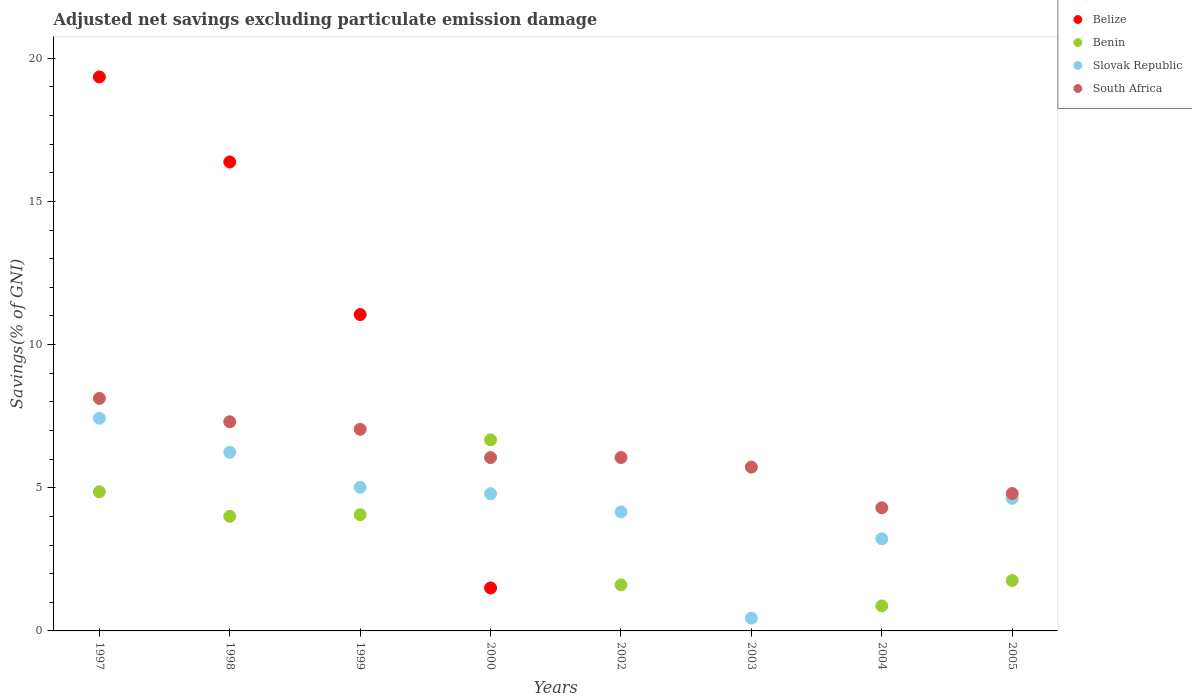Is the number of dotlines equal to the number of legend labels?
Your answer should be very brief. No. What is the adjusted net savings in Belize in 2000?
Your answer should be very brief. 1.5. Across all years, what is the maximum adjusted net savings in Benin?
Keep it short and to the point. 6.67. Across all years, what is the minimum adjusted net savings in Slovak Republic?
Provide a short and direct response. 0.44. What is the total adjusted net savings in Slovak Republic in the graph?
Offer a terse response. 35.91. What is the difference between the adjusted net savings in South Africa in 1998 and that in 2004?
Offer a very short reply. 3. What is the difference between the adjusted net savings in Benin in 2004 and the adjusted net savings in South Africa in 2005?
Offer a very short reply. -3.92. What is the average adjusted net savings in Slovak Republic per year?
Provide a short and direct response. 4.49. In the year 2000, what is the difference between the adjusted net savings in Benin and adjusted net savings in Belize?
Offer a terse response. 5.17. What is the ratio of the adjusted net savings in South Africa in 1997 to that in 1998?
Provide a short and direct response. 1.11. Is the adjusted net savings in Benin in 2000 less than that in 2005?
Ensure brevity in your answer.  No. Is the difference between the adjusted net savings in Benin in 1997 and 2000 greater than the difference between the adjusted net savings in Belize in 1997 and 2000?
Your answer should be compact. No. What is the difference between the highest and the second highest adjusted net savings in South Africa?
Your answer should be compact. 0.81. What is the difference between the highest and the lowest adjusted net savings in South Africa?
Keep it short and to the point. 3.82. In how many years, is the adjusted net savings in Belize greater than the average adjusted net savings in Belize taken over all years?
Give a very brief answer. 3. Is the sum of the adjusted net savings in South Africa in 2000 and 2002 greater than the maximum adjusted net savings in Belize across all years?
Your response must be concise. No. Is it the case that in every year, the sum of the adjusted net savings in Slovak Republic and adjusted net savings in South Africa  is greater than the sum of adjusted net savings in Benin and adjusted net savings in Belize?
Offer a very short reply. No. Is it the case that in every year, the sum of the adjusted net savings in Slovak Republic and adjusted net savings in Benin  is greater than the adjusted net savings in South Africa?
Your response must be concise. No. Does the adjusted net savings in Benin monotonically increase over the years?
Your answer should be compact. No. What is the difference between two consecutive major ticks on the Y-axis?
Make the answer very short. 5. Does the graph contain any zero values?
Provide a succinct answer. Yes. Does the graph contain grids?
Ensure brevity in your answer.  No. What is the title of the graph?
Ensure brevity in your answer.  Adjusted net savings excluding particulate emission damage. What is the label or title of the Y-axis?
Your response must be concise. Savings(% of GNI). What is the Savings(% of GNI) of Belize in 1997?
Your answer should be compact. 19.35. What is the Savings(% of GNI) in Benin in 1997?
Your answer should be compact. 4.86. What is the Savings(% of GNI) of Slovak Republic in 1997?
Your answer should be compact. 7.43. What is the Savings(% of GNI) in South Africa in 1997?
Provide a succinct answer. 8.12. What is the Savings(% of GNI) in Belize in 1998?
Ensure brevity in your answer.  16.38. What is the Savings(% of GNI) of Benin in 1998?
Give a very brief answer. 4. What is the Savings(% of GNI) in Slovak Republic in 1998?
Ensure brevity in your answer.  6.24. What is the Savings(% of GNI) of South Africa in 1998?
Provide a succinct answer. 7.3. What is the Savings(% of GNI) in Belize in 1999?
Your answer should be very brief. 11.05. What is the Savings(% of GNI) of Benin in 1999?
Provide a succinct answer. 4.06. What is the Savings(% of GNI) of Slovak Republic in 1999?
Offer a very short reply. 5.02. What is the Savings(% of GNI) in South Africa in 1999?
Offer a very short reply. 7.04. What is the Savings(% of GNI) of Belize in 2000?
Provide a succinct answer. 1.5. What is the Savings(% of GNI) of Benin in 2000?
Ensure brevity in your answer.  6.67. What is the Savings(% of GNI) of Slovak Republic in 2000?
Provide a short and direct response. 4.79. What is the Savings(% of GNI) in South Africa in 2000?
Your response must be concise. 6.05. What is the Savings(% of GNI) of Benin in 2002?
Your answer should be very brief. 1.61. What is the Savings(% of GNI) in Slovak Republic in 2002?
Offer a terse response. 4.16. What is the Savings(% of GNI) in South Africa in 2002?
Give a very brief answer. 6.05. What is the Savings(% of GNI) of Belize in 2003?
Provide a succinct answer. 0. What is the Savings(% of GNI) in Slovak Republic in 2003?
Your answer should be very brief. 0.44. What is the Savings(% of GNI) in South Africa in 2003?
Your response must be concise. 5.72. What is the Savings(% of GNI) in Belize in 2004?
Offer a terse response. 0. What is the Savings(% of GNI) in Benin in 2004?
Your answer should be very brief. 0.87. What is the Savings(% of GNI) of Slovak Republic in 2004?
Offer a very short reply. 3.22. What is the Savings(% of GNI) in South Africa in 2004?
Ensure brevity in your answer.  4.3. What is the Savings(% of GNI) in Belize in 2005?
Your answer should be very brief. 0. What is the Savings(% of GNI) in Benin in 2005?
Provide a succinct answer. 1.76. What is the Savings(% of GNI) of Slovak Republic in 2005?
Provide a short and direct response. 4.63. What is the Savings(% of GNI) in South Africa in 2005?
Provide a short and direct response. 4.8. Across all years, what is the maximum Savings(% of GNI) of Belize?
Offer a very short reply. 19.35. Across all years, what is the maximum Savings(% of GNI) of Benin?
Your answer should be very brief. 6.67. Across all years, what is the maximum Savings(% of GNI) in Slovak Republic?
Your answer should be compact. 7.43. Across all years, what is the maximum Savings(% of GNI) in South Africa?
Ensure brevity in your answer.  8.12. Across all years, what is the minimum Savings(% of GNI) of Slovak Republic?
Your response must be concise. 0.44. Across all years, what is the minimum Savings(% of GNI) of South Africa?
Provide a short and direct response. 4.3. What is the total Savings(% of GNI) in Belize in the graph?
Make the answer very short. 48.27. What is the total Savings(% of GNI) in Benin in the graph?
Offer a very short reply. 23.83. What is the total Savings(% of GNI) of Slovak Republic in the graph?
Your answer should be very brief. 35.91. What is the total Savings(% of GNI) in South Africa in the graph?
Make the answer very short. 49.39. What is the difference between the Savings(% of GNI) in Belize in 1997 and that in 1998?
Give a very brief answer. 2.97. What is the difference between the Savings(% of GNI) in Benin in 1997 and that in 1998?
Provide a succinct answer. 0.86. What is the difference between the Savings(% of GNI) in Slovak Republic in 1997 and that in 1998?
Give a very brief answer. 1.19. What is the difference between the Savings(% of GNI) of South Africa in 1997 and that in 1998?
Ensure brevity in your answer.  0.81. What is the difference between the Savings(% of GNI) in Belize in 1997 and that in 1999?
Your answer should be very brief. 8.3. What is the difference between the Savings(% of GNI) in Benin in 1997 and that in 1999?
Your answer should be very brief. 0.8. What is the difference between the Savings(% of GNI) of Slovak Republic in 1997 and that in 1999?
Ensure brevity in your answer.  2.41. What is the difference between the Savings(% of GNI) of South Africa in 1997 and that in 1999?
Keep it short and to the point. 1.08. What is the difference between the Savings(% of GNI) in Belize in 1997 and that in 2000?
Make the answer very short. 17.85. What is the difference between the Savings(% of GNI) of Benin in 1997 and that in 2000?
Give a very brief answer. -1.81. What is the difference between the Savings(% of GNI) in Slovak Republic in 1997 and that in 2000?
Offer a very short reply. 2.64. What is the difference between the Savings(% of GNI) of South Africa in 1997 and that in 2000?
Offer a terse response. 2.07. What is the difference between the Savings(% of GNI) of Benin in 1997 and that in 2002?
Your response must be concise. 3.25. What is the difference between the Savings(% of GNI) in Slovak Republic in 1997 and that in 2002?
Make the answer very short. 3.27. What is the difference between the Savings(% of GNI) in South Africa in 1997 and that in 2002?
Your answer should be compact. 2.06. What is the difference between the Savings(% of GNI) in Slovak Republic in 1997 and that in 2003?
Keep it short and to the point. 6.98. What is the difference between the Savings(% of GNI) of South Africa in 1997 and that in 2003?
Make the answer very short. 2.4. What is the difference between the Savings(% of GNI) of Benin in 1997 and that in 2004?
Ensure brevity in your answer.  3.99. What is the difference between the Savings(% of GNI) in Slovak Republic in 1997 and that in 2004?
Provide a short and direct response. 4.21. What is the difference between the Savings(% of GNI) in South Africa in 1997 and that in 2004?
Offer a very short reply. 3.82. What is the difference between the Savings(% of GNI) of Slovak Republic in 1997 and that in 2005?
Your answer should be very brief. 2.8. What is the difference between the Savings(% of GNI) of South Africa in 1997 and that in 2005?
Provide a short and direct response. 3.32. What is the difference between the Savings(% of GNI) of Belize in 1998 and that in 1999?
Provide a short and direct response. 5.33. What is the difference between the Savings(% of GNI) of Benin in 1998 and that in 1999?
Ensure brevity in your answer.  -0.06. What is the difference between the Savings(% of GNI) in Slovak Republic in 1998 and that in 1999?
Keep it short and to the point. 1.22. What is the difference between the Savings(% of GNI) of South Africa in 1998 and that in 1999?
Your response must be concise. 0.26. What is the difference between the Savings(% of GNI) in Belize in 1998 and that in 2000?
Make the answer very short. 14.88. What is the difference between the Savings(% of GNI) of Benin in 1998 and that in 2000?
Give a very brief answer. -2.67. What is the difference between the Savings(% of GNI) in Slovak Republic in 1998 and that in 2000?
Make the answer very short. 1.45. What is the difference between the Savings(% of GNI) of South Africa in 1998 and that in 2000?
Give a very brief answer. 1.25. What is the difference between the Savings(% of GNI) in Benin in 1998 and that in 2002?
Ensure brevity in your answer.  2.39. What is the difference between the Savings(% of GNI) of Slovak Republic in 1998 and that in 2002?
Make the answer very short. 2.08. What is the difference between the Savings(% of GNI) in South Africa in 1998 and that in 2002?
Provide a short and direct response. 1.25. What is the difference between the Savings(% of GNI) in Slovak Republic in 1998 and that in 2003?
Give a very brief answer. 5.79. What is the difference between the Savings(% of GNI) in South Africa in 1998 and that in 2003?
Provide a short and direct response. 1.58. What is the difference between the Savings(% of GNI) in Benin in 1998 and that in 2004?
Ensure brevity in your answer.  3.13. What is the difference between the Savings(% of GNI) of Slovak Republic in 1998 and that in 2004?
Your answer should be very brief. 3.02. What is the difference between the Savings(% of GNI) in South Africa in 1998 and that in 2004?
Your answer should be very brief. 3. What is the difference between the Savings(% of GNI) in Benin in 1998 and that in 2005?
Keep it short and to the point. 2.24. What is the difference between the Savings(% of GNI) in Slovak Republic in 1998 and that in 2005?
Provide a succinct answer. 1.61. What is the difference between the Savings(% of GNI) of South Africa in 1998 and that in 2005?
Provide a short and direct response. 2.51. What is the difference between the Savings(% of GNI) of Belize in 1999 and that in 2000?
Your answer should be very brief. 9.55. What is the difference between the Savings(% of GNI) in Benin in 1999 and that in 2000?
Make the answer very short. -2.62. What is the difference between the Savings(% of GNI) in Slovak Republic in 1999 and that in 2000?
Provide a short and direct response. 0.23. What is the difference between the Savings(% of GNI) in South Africa in 1999 and that in 2000?
Provide a short and direct response. 0.99. What is the difference between the Savings(% of GNI) in Benin in 1999 and that in 2002?
Offer a very short reply. 2.45. What is the difference between the Savings(% of GNI) in Slovak Republic in 1999 and that in 2002?
Give a very brief answer. 0.86. What is the difference between the Savings(% of GNI) of South Africa in 1999 and that in 2002?
Your answer should be compact. 0.99. What is the difference between the Savings(% of GNI) of Slovak Republic in 1999 and that in 2003?
Provide a succinct answer. 4.57. What is the difference between the Savings(% of GNI) in South Africa in 1999 and that in 2003?
Keep it short and to the point. 1.32. What is the difference between the Savings(% of GNI) of Benin in 1999 and that in 2004?
Make the answer very short. 3.18. What is the difference between the Savings(% of GNI) in Slovak Republic in 1999 and that in 2004?
Provide a short and direct response. 1.8. What is the difference between the Savings(% of GNI) in South Africa in 1999 and that in 2004?
Keep it short and to the point. 2.74. What is the difference between the Savings(% of GNI) of Benin in 1999 and that in 2005?
Ensure brevity in your answer.  2.3. What is the difference between the Savings(% of GNI) of Slovak Republic in 1999 and that in 2005?
Your answer should be very brief. 0.39. What is the difference between the Savings(% of GNI) in South Africa in 1999 and that in 2005?
Make the answer very short. 2.24. What is the difference between the Savings(% of GNI) of Benin in 2000 and that in 2002?
Your answer should be compact. 5.07. What is the difference between the Savings(% of GNI) in Slovak Republic in 2000 and that in 2002?
Offer a very short reply. 0.63. What is the difference between the Savings(% of GNI) in South Africa in 2000 and that in 2002?
Provide a short and direct response. -0. What is the difference between the Savings(% of GNI) in Slovak Republic in 2000 and that in 2003?
Keep it short and to the point. 4.34. What is the difference between the Savings(% of GNI) in South Africa in 2000 and that in 2003?
Ensure brevity in your answer.  0.33. What is the difference between the Savings(% of GNI) in Benin in 2000 and that in 2004?
Provide a short and direct response. 5.8. What is the difference between the Savings(% of GNI) in Slovak Republic in 2000 and that in 2004?
Offer a terse response. 1.57. What is the difference between the Savings(% of GNI) of South Africa in 2000 and that in 2004?
Make the answer very short. 1.75. What is the difference between the Savings(% of GNI) of Benin in 2000 and that in 2005?
Make the answer very short. 4.91. What is the difference between the Savings(% of GNI) of Slovak Republic in 2000 and that in 2005?
Give a very brief answer. 0.16. What is the difference between the Savings(% of GNI) in South Africa in 2000 and that in 2005?
Offer a terse response. 1.25. What is the difference between the Savings(% of GNI) of Slovak Republic in 2002 and that in 2003?
Provide a short and direct response. 3.71. What is the difference between the Savings(% of GNI) in South Africa in 2002 and that in 2003?
Offer a terse response. 0.33. What is the difference between the Savings(% of GNI) in Benin in 2002 and that in 2004?
Ensure brevity in your answer.  0.73. What is the difference between the Savings(% of GNI) in Slovak Republic in 2002 and that in 2004?
Offer a terse response. 0.94. What is the difference between the Savings(% of GNI) of South Africa in 2002 and that in 2004?
Keep it short and to the point. 1.75. What is the difference between the Savings(% of GNI) in Benin in 2002 and that in 2005?
Keep it short and to the point. -0.15. What is the difference between the Savings(% of GNI) of Slovak Republic in 2002 and that in 2005?
Your response must be concise. -0.47. What is the difference between the Savings(% of GNI) in South Africa in 2002 and that in 2005?
Your answer should be very brief. 1.26. What is the difference between the Savings(% of GNI) of Slovak Republic in 2003 and that in 2004?
Your answer should be very brief. -2.77. What is the difference between the Savings(% of GNI) of South Africa in 2003 and that in 2004?
Provide a succinct answer. 1.42. What is the difference between the Savings(% of GNI) in Slovak Republic in 2003 and that in 2005?
Give a very brief answer. -4.18. What is the difference between the Savings(% of GNI) in South Africa in 2003 and that in 2005?
Ensure brevity in your answer.  0.92. What is the difference between the Savings(% of GNI) in Benin in 2004 and that in 2005?
Offer a terse response. -0.89. What is the difference between the Savings(% of GNI) in Slovak Republic in 2004 and that in 2005?
Your answer should be compact. -1.41. What is the difference between the Savings(% of GNI) of South Africa in 2004 and that in 2005?
Offer a very short reply. -0.5. What is the difference between the Savings(% of GNI) in Belize in 1997 and the Savings(% of GNI) in Benin in 1998?
Ensure brevity in your answer.  15.35. What is the difference between the Savings(% of GNI) of Belize in 1997 and the Savings(% of GNI) of Slovak Republic in 1998?
Give a very brief answer. 13.11. What is the difference between the Savings(% of GNI) of Belize in 1997 and the Savings(% of GNI) of South Africa in 1998?
Provide a short and direct response. 12.04. What is the difference between the Savings(% of GNI) in Benin in 1997 and the Savings(% of GNI) in Slovak Republic in 1998?
Provide a succinct answer. -1.38. What is the difference between the Savings(% of GNI) in Benin in 1997 and the Savings(% of GNI) in South Africa in 1998?
Ensure brevity in your answer.  -2.45. What is the difference between the Savings(% of GNI) in Slovak Republic in 1997 and the Savings(% of GNI) in South Africa in 1998?
Give a very brief answer. 0.12. What is the difference between the Savings(% of GNI) of Belize in 1997 and the Savings(% of GNI) of Benin in 1999?
Make the answer very short. 15.29. What is the difference between the Savings(% of GNI) in Belize in 1997 and the Savings(% of GNI) in Slovak Republic in 1999?
Offer a terse response. 14.33. What is the difference between the Savings(% of GNI) in Belize in 1997 and the Savings(% of GNI) in South Africa in 1999?
Provide a succinct answer. 12.31. What is the difference between the Savings(% of GNI) of Benin in 1997 and the Savings(% of GNI) of Slovak Republic in 1999?
Provide a short and direct response. -0.16. What is the difference between the Savings(% of GNI) of Benin in 1997 and the Savings(% of GNI) of South Africa in 1999?
Keep it short and to the point. -2.18. What is the difference between the Savings(% of GNI) in Slovak Republic in 1997 and the Savings(% of GNI) in South Africa in 1999?
Provide a succinct answer. 0.39. What is the difference between the Savings(% of GNI) in Belize in 1997 and the Savings(% of GNI) in Benin in 2000?
Your answer should be very brief. 12.67. What is the difference between the Savings(% of GNI) of Belize in 1997 and the Savings(% of GNI) of Slovak Republic in 2000?
Make the answer very short. 14.56. What is the difference between the Savings(% of GNI) in Belize in 1997 and the Savings(% of GNI) in South Africa in 2000?
Provide a succinct answer. 13.29. What is the difference between the Savings(% of GNI) of Benin in 1997 and the Savings(% of GNI) of Slovak Republic in 2000?
Ensure brevity in your answer.  0.07. What is the difference between the Savings(% of GNI) in Benin in 1997 and the Savings(% of GNI) in South Africa in 2000?
Offer a terse response. -1.19. What is the difference between the Savings(% of GNI) in Slovak Republic in 1997 and the Savings(% of GNI) in South Africa in 2000?
Make the answer very short. 1.37. What is the difference between the Savings(% of GNI) in Belize in 1997 and the Savings(% of GNI) in Benin in 2002?
Make the answer very short. 17.74. What is the difference between the Savings(% of GNI) of Belize in 1997 and the Savings(% of GNI) of Slovak Republic in 2002?
Keep it short and to the point. 15.19. What is the difference between the Savings(% of GNI) of Belize in 1997 and the Savings(% of GNI) of South Africa in 2002?
Provide a short and direct response. 13.29. What is the difference between the Savings(% of GNI) in Benin in 1997 and the Savings(% of GNI) in Slovak Republic in 2002?
Provide a succinct answer. 0.7. What is the difference between the Savings(% of GNI) in Benin in 1997 and the Savings(% of GNI) in South Africa in 2002?
Offer a terse response. -1.2. What is the difference between the Savings(% of GNI) of Slovak Republic in 1997 and the Savings(% of GNI) of South Africa in 2002?
Your answer should be compact. 1.37. What is the difference between the Savings(% of GNI) in Belize in 1997 and the Savings(% of GNI) in Slovak Republic in 2003?
Ensure brevity in your answer.  18.9. What is the difference between the Savings(% of GNI) of Belize in 1997 and the Savings(% of GNI) of South Africa in 2003?
Your response must be concise. 13.63. What is the difference between the Savings(% of GNI) of Benin in 1997 and the Savings(% of GNI) of Slovak Republic in 2003?
Offer a terse response. 4.41. What is the difference between the Savings(% of GNI) in Benin in 1997 and the Savings(% of GNI) in South Africa in 2003?
Your answer should be very brief. -0.86. What is the difference between the Savings(% of GNI) in Slovak Republic in 1997 and the Savings(% of GNI) in South Africa in 2003?
Your response must be concise. 1.71. What is the difference between the Savings(% of GNI) of Belize in 1997 and the Savings(% of GNI) of Benin in 2004?
Your answer should be very brief. 18.47. What is the difference between the Savings(% of GNI) in Belize in 1997 and the Savings(% of GNI) in Slovak Republic in 2004?
Your response must be concise. 16.13. What is the difference between the Savings(% of GNI) of Belize in 1997 and the Savings(% of GNI) of South Africa in 2004?
Keep it short and to the point. 15.05. What is the difference between the Savings(% of GNI) in Benin in 1997 and the Savings(% of GNI) in Slovak Republic in 2004?
Offer a terse response. 1.64. What is the difference between the Savings(% of GNI) in Benin in 1997 and the Savings(% of GNI) in South Africa in 2004?
Your answer should be very brief. 0.56. What is the difference between the Savings(% of GNI) of Slovak Republic in 1997 and the Savings(% of GNI) of South Africa in 2004?
Your answer should be compact. 3.13. What is the difference between the Savings(% of GNI) in Belize in 1997 and the Savings(% of GNI) in Benin in 2005?
Offer a terse response. 17.59. What is the difference between the Savings(% of GNI) of Belize in 1997 and the Savings(% of GNI) of Slovak Republic in 2005?
Keep it short and to the point. 14.72. What is the difference between the Savings(% of GNI) of Belize in 1997 and the Savings(% of GNI) of South Africa in 2005?
Ensure brevity in your answer.  14.55. What is the difference between the Savings(% of GNI) of Benin in 1997 and the Savings(% of GNI) of Slovak Republic in 2005?
Provide a succinct answer. 0.23. What is the difference between the Savings(% of GNI) in Benin in 1997 and the Savings(% of GNI) in South Africa in 2005?
Provide a succinct answer. 0.06. What is the difference between the Savings(% of GNI) of Slovak Republic in 1997 and the Savings(% of GNI) of South Africa in 2005?
Offer a very short reply. 2.63. What is the difference between the Savings(% of GNI) in Belize in 1998 and the Savings(% of GNI) in Benin in 1999?
Provide a short and direct response. 12.32. What is the difference between the Savings(% of GNI) in Belize in 1998 and the Savings(% of GNI) in Slovak Republic in 1999?
Keep it short and to the point. 11.36. What is the difference between the Savings(% of GNI) in Belize in 1998 and the Savings(% of GNI) in South Africa in 1999?
Keep it short and to the point. 9.34. What is the difference between the Savings(% of GNI) of Benin in 1998 and the Savings(% of GNI) of Slovak Republic in 1999?
Your response must be concise. -1.01. What is the difference between the Savings(% of GNI) in Benin in 1998 and the Savings(% of GNI) in South Africa in 1999?
Provide a succinct answer. -3.04. What is the difference between the Savings(% of GNI) of Slovak Republic in 1998 and the Savings(% of GNI) of South Africa in 1999?
Give a very brief answer. -0.8. What is the difference between the Savings(% of GNI) in Belize in 1998 and the Savings(% of GNI) in Benin in 2000?
Provide a short and direct response. 9.7. What is the difference between the Savings(% of GNI) in Belize in 1998 and the Savings(% of GNI) in Slovak Republic in 2000?
Offer a very short reply. 11.59. What is the difference between the Savings(% of GNI) in Belize in 1998 and the Savings(% of GNI) in South Africa in 2000?
Keep it short and to the point. 10.32. What is the difference between the Savings(% of GNI) in Benin in 1998 and the Savings(% of GNI) in Slovak Republic in 2000?
Offer a very short reply. -0.79. What is the difference between the Savings(% of GNI) of Benin in 1998 and the Savings(% of GNI) of South Africa in 2000?
Your answer should be very brief. -2.05. What is the difference between the Savings(% of GNI) in Slovak Republic in 1998 and the Savings(% of GNI) in South Africa in 2000?
Ensure brevity in your answer.  0.19. What is the difference between the Savings(% of GNI) of Belize in 1998 and the Savings(% of GNI) of Benin in 2002?
Offer a very short reply. 14.77. What is the difference between the Savings(% of GNI) of Belize in 1998 and the Savings(% of GNI) of Slovak Republic in 2002?
Ensure brevity in your answer.  12.22. What is the difference between the Savings(% of GNI) in Belize in 1998 and the Savings(% of GNI) in South Africa in 2002?
Your answer should be compact. 10.32. What is the difference between the Savings(% of GNI) in Benin in 1998 and the Savings(% of GNI) in Slovak Republic in 2002?
Keep it short and to the point. -0.16. What is the difference between the Savings(% of GNI) in Benin in 1998 and the Savings(% of GNI) in South Africa in 2002?
Offer a terse response. -2.05. What is the difference between the Savings(% of GNI) in Slovak Republic in 1998 and the Savings(% of GNI) in South Africa in 2002?
Offer a very short reply. 0.18. What is the difference between the Savings(% of GNI) of Belize in 1998 and the Savings(% of GNI) of Slovak Republic in 2003?
Offer a terse response. 15.93. What is the difference between the Savings(% of GNI) in Belize in 1998 and the Savings(% of GNI) in South Africa in 2003?
Ensure brevity in your answer.  10.66. What is the difference between the Savings(% of GNI) of Benin in 1998 and the Savings(% of GNI) of Slovak Republic in 2003?
Ensure brevity in your answer.  3.56. What is the difference between the Savings(% of GNI) of Benin in 1998 and the Savings(% of GNI) of South Africa in 2003?
Provide a short and direct response. -1.72. What is the difference between the Savings(% of GNI) of Slovak Republic in 1998 and the Savings(% of GNI) of South Africa in 2003?
Make the answer very short. 0.52. What is the difference between the Savings(% of GNI) in Belize in 1998 and the Savings(% of GNI) in Benin in 2004?
Your response must be concise. 15.5. What is the difference between the Savings(% of GNI) of Belize in 1998 and the Savings(% of GNI) of Slovak Republic in 2004?
Provide a succinct answer. 13.16. What is the difference between the Savings(% of GNI) in Belize in 1998 and the Savings(% of GNI) in South Africa in 2004?
Your answer should be compact. 12.08. What is the difference between the Savings(% of GNI) in Benin in 1998 and the Savings(% of GNI) in Slovak Republic in 2004?
Ensure brevity in your answer.  0.78. What is the difference between the Savings(% of GNI) in Benin in 1998 and the Savings(% of GNI) in South Africa in 2004?
Your answer should be very brief. -0.3. What is the difference between the Savings(% of GNI) of Slovak Republic in 1998 and the Savings(% of GNI) of South Africa in 2004?
Offer a very short reply. 1.94. What is the difference between the Savings(% of GNI) in Belize in 1998 and the Savings(% of GNI) in Benin in 2005?
Provide a short and direct response. 14.62. What is the difference between the Savings(% of GNI) in Belize in 1998 and the Savings(% of GNI) in Slovak Republic in 2005?
Keep it short and to the point. 11.75. What is the difference between the Savings(% of GNI) of Belize in 1998 and the Savings(% of GNI) of South Africa in 2005?
Make the answer very short. 11.58. What is the difference between the Savings(% of GNI) in Benin in 1998 and the Savings(% of GNI) in Slovak Republic in 2005?
Offer a terse response. -0.63. What is the difference between the Savings(% of GNI) of Benin in 1998 and the Savings(% of GNI) of South Africa in 2005?
Your answer should be very brief. -0.8. What is the difference between the Savings(% of GNI) of Slovak Republic in 1998 and the Savings(% of GNI) of South Africa in 2005?
Keep it short and to the point. 1.44. What is the difference between the Savings(% of GNI) in Belize in 1999 and the Savings(% of GNI) in Benin in 2000?
Ensure brevity in your answer.  4.37. What is the difference between the Savings(% of GNI) of Belize in 1999 and the Savings(% of GNI) of Slovak Republic in 2000?
Offer a very short reply. 6.26. What is the difference between the Savings(% of GNI) in Belize in 1999 and the Savings(% of GNI) in South Africa in 2000?
Offer a very short reply. 4.99. What is the difference between the Savings(% of GNI) in Benin in 1999 and the Savings(% of GNI) in Slovak Republic in 2000?
Make the answer very short. -0.73. What is the difference between the Savings(% of GNI) of Benin in 1999 and the Savings(% of GNI) of South Africa in 2000?
Make the answer very short. -2. What is the difference between the Savings(% of GNI) in Slovak Republic in 1999 and the Savings(% of GNI) in South Africa in 2000?
Make the answer very short. -1.04. What is the difference between the Savings(% of GNI) in Belize in 1999 and the Savings(% of GNI) in Benin in 2002?
Ensure brevity in your answer.  9.44. What is the difference between the Savings(% of GNI) in Belize in 1999 and the Savings(% of GNI) in Slovak Republic in 2002?
Your answer should be very brief. 6.89. What is the difference between the Savings(% of GNI) in Belize in 1999 and the Savings(% of GNI) in South Africa in 2002?
Ensure brevity in your answer.  4.99. What is the difference between the Savings(% of GNI) of Benin in 1999 and the Savings(% of GNI) of Slovak Republic in 2002?
Offer a very short reply. -0.1. What is the difference between the Savings(% of GNI) of Benin in 1999 and the Savings(% of GNI) of South Africa in 2002?
Your answer should be compact. -2. What is the difference between the Savings(% of GNI) of Slovak Republic in 1999 and the Savings(% of GNI) of South Africa in 2002?
Offer a very short reply. -1.04. What is the difference between the Savings(% of GNI) of Belize in 1999 and the Savings(% of GNI) of Slovak Republic in 2003?
Provide a short and direct response. 10.6. What is the difference between the Savings(% of GNI) in Belize in 1999 and the Savings(% of GNI) in South Africa in 2003?
Keep it short and to the point. 5.33. What is the difference between the Savings(% of GNI) in Benin in 1999 and the Savings(% of GNI) in Slovak Republic in 2003?
Offer a very short reply. 3.61. What is the difference between the Savings(% of GNI) of Benin in 1999 and the Savings(% of GNI) of South Africa in 2003?
Ensure brevity in your answer.  -1.66. What is the difference between the Savings(% of GNI) in Slovak Republic in 1999 and the Savings(% of GNI) in South Africa in 2003?
Provide a short and direct response. -0.71. What is the difference between the Savings(% of GNI) of Belize in 1999 and the Savings(% of GNI) of Benin in 2004?
Make the answer very short. 10.17. What is the difference between the Savings(% of GNI) of Belize in 1999 and the Savings(% of GNI) of Slovak Republic in 2004?
Give a very brief answer. 7.83. What is the difference between the Savings(% of GNI) of Belize in 1999 and the Savings(% of GNI) of South Africa in 2004?
Ensure brevity in your answer.  6.75. What is the difference between the Savings(% of GNI) in Benin in 1999 and the Savings(% of GNI) in Slovak Republic in 2004?
Your response must be concise. 0.84. What is the difference between the Savings(% of GNI) of Benin in 1999 and the Savings(% of GNI) of South Africa in 2004?
Provide a succinct answer. -0.24. What is the difference between the Savings(% of GNI) in Slovak Republic in 1999 and the Savings(% of GNI) in South Africa in 2004?
Provide a short and direct response. 0.72. What is the difference between the Savings(% of GNI) of Belize in 1999 and the Savings(% of GNI) of Benin in 2005?
Ensure brevity in your answer.  9.29. What is the difference between the Savings(% of GNI) in Belize in 1999 and the Savings(% of GNI) in Slovak Republic in 2005?
Ensure brevity in your answer.  6.42. What is the difference between the Savings(% of GNI) in Belize in 1999 and the Savings(% of GNI) in South Africa in 2005?
Your answer should be compact. 6.25. What is the difference between the Savings(% of GNI) of Benin in 1999 and the Savings(% of GNI) of Slovak Republic in 2005?
Make the answer very short. -0.57. What is the difference between the Savings(% of GNI) of Benin in 1999 and the Savings(% of GNI) of South Africa in 2005?
Keep it short and to the point. -0.74. What is the difference between the Savings(% of GNI) of Slovak Republic in 1999 and the Savings(% of GNI) of South Africa in 2005?
Your response must be concise. 0.22. What is the difference between the Savings(% of GNI) in Belize in 2000 and the Savings(% of GNI) in Benin in 2002?
Your response must be concise. -0.11. What is the difference between the Savings(% of GNI) in Belize in 2000 and the Savings(% of GNI) in Slovak Republic in 2002?
Your answer should be very brief. -2.66. What is the difference between the Savings(% of GNI) of Belize in 2000 and the Savings(% of GNI) of South Africa in 2002?
Your response must be concise. -4.55. What is the difference between the Savings(% of GNI) in Benin in 2000 and the Savings(% of GNI) in Slovak Republic in 2002?
Offer a very short reply. 2.52. What is the difference between the Savings(% of GNI) of Benin in 2000 and the Savings(% of GNI) of South Africa in 2002?
Ensure brevity in your answer.  0.62. What is the difference between the Savings(% of GNI) in Slovak Republic in 2000 and the Savings(% of GNI) in South Africa in 2002?
Provide a short and direct response. -1.27. What is the difference between the Savings(% of GNI) in Belize in 2000 and the Savings(% of GNI) in Slovak Republic in 2003?
Your answer should be very brief. 1.06. What is the difference between the Savings(% of GNI) of Belize in 2000 and the Savings(% of GNI) of South Africa in 2003?
Your answer should be very brief. -4.22. What is the difference between the Savings(% of GNI) in Benin in 2000 and the Savings(% of GNI) in Slovak Republic in 2003?
Ensure brevity in your answer.  6.23. What is the difference between the Savings(% of GNI) in Benin in 2000 and the Savings(% of GNI) in South Africa in 2003?
Ensure brevity in your answer.  0.95. What is the difference between the Savings(% of GNI) of Slovak Republic in 2000 and the Savings(% of GNI) of South Africa in 2003?
Offer a terse response. -0.93. What is the difference between the Savings(% of GNI) of Belize in 2000 and the Savings(% of GNI) of Benin in 2004?
Make the answer very short. 0.63. What is the difference between the Savings(% of GNI) in Belize in 2000 and the Savings(% of GNI) in Slovak Republic in 2004?
Make the answer very short. -1.72. What is the difference between the Savings(% of GNI) of Belize in 2000 and the Savings(% of GNI) of South Africa in 2004?
Offer a very short reply. -2.8. What is the difference between the Savings(% of GNI) of Benin in 2000 and the Savings(% of GNI) of Slovak Republic in 2004?
Your response must be concise. 3.46. What is the difference between the Savings(% of GNI) of Benin in 2000 and the Savings(% of GNI) of South Africa in 2004?
Your response must be concise. 2.37. What is the difference between the Savings(% of GNI) in Slovak Republic in 2000 and the Savings(% of GNI) in South Africa in 2004?
Offer a very short reply. 0.49. What is the difference between the Savings(% of GNI) in Belize in 2000 and the Savings(% of GNI) in Benin in 2005?
Ensure brevity in your answer.  -0.26. What is the difference between the Savings(% of GNI) of Belize in 2000 and the Savings(% of GNI) of Slovak Republic in 2005?
Offer a terse response. -3.13. What is the difference between the Savings(% of GNI) of Belize in 2000 and the Savings(% of GNI) of South Africa in 2005?
Offer a terse response. -3.3. What is the difference between the Savings(% of GNI) in Benin in 2000 and the Savings(% of GNI) in Slovak Republic in 2005?
Your answer should be very brief. 2.04. What is the difference between the Savings(% of GNI) of Benin in 2000 and the Savings(% of GNI) of South Africa in 2005?
Offer a terse response. 1.87. What is the difference between the Savings(% of GNI) of Slovak Republic in 2000 and the Savings(% of GNI) of South Africa in 2005?
Give a very brief answer. -0.01. What is the difference between the Savings(% of GNI) of Benin in 2002 and the Savings(% of GNI) of Slovak Republic in 2003?
Give a very brief answer. 1.16. What is the difference between the Savings(% of GNI) of Benin in 2002 and the Savings(% of GNI) of South Africa in 2003?
Give a very brief answer. -4.11. What is the difference between the Savings(% of GNI) in Slovak Republic in 2002 and the Savings(% of GNI) in South Africa in 2003?
Your response must be concise. -1.56. What is the difference between the Savings(% of GNI) in Benin in 2002 and the Savings(% of GNI) in Slovak Republic in 2004?
Offer a very short reply. -1.61. What is the difference between the Savings(% of GNI) in Benin in 2002 and the Savings(% of GNI) in South Africa in 2004?
Offer a terse response. -2.69. What is the difference between the Savings(% of GNI) of Slovak Republic in 2002 and the Savings(% of GNI) of South Africa in 2004?
Your response must be concise. -0.14. What is the difference between the Savings(% of GNI) in Benin in 2002 and the Savings(% of GNI) in Slovak Republic in 2005?
Your answer should be very brief. -3.02. What is the difference between the Savings(% of GNI) of Benin in 2002 and the Savings(% of GNI) of South Africa in 2005?
Offer a very short reply. -3.19. What is the difference between the Savings(% of GNI) in Slovak Republic in 2002 and the Savings(% of GNI) in South Africa in 2005?
Offer a terse response. -0.64. What is the difference between the Savings(% of GNI) of Slovak Republic in 2003 and the Savings(% of GNI) of South Africa in 2004?
Keep it short and to the point. -3.86. What is the difference between the Savings(% of GNI) of Slovak Republic in 2003 and the Savings(% of GNI) of South Africa in 2005?
Your response must be concise. -4.35. What is the difference between the Savings(% of GNI) of Benin in 2004 and the Savings(% of GNI) of Slovak Republic in 2005?
Keep it short and to the point. -3.76. What is the difference between the Savings(% of GNI) in Benin in 2004 and the Savings(% of GNI) in South Africa in 2005?
Your answer should be compact. -3.92. What is the difference between the Savings(% of GNI) in Slovak Republic in 2004 and the Savings(% of GNI) in South Africa in 2005?
Offer a terse response. -1.58. What is the average Savings(% of GNI) in Belize per year?
Make the answer very short. 6.03. What is the average Savings(% of GNI) of Benin per year?
Keep it short and to the point. 2.98. What is the average Savings(% of GNI) in Slovak Republic per year?
Make the answer very short. 4.49. What is the average Savings(% of GNI) of South Africa per year?
Keep it short and to the point. 6.17. In the year 1997, what is the difference between the Savings(% of GNI) in Belize and Savings(% of GNI) in Benin?
Provide a succinct answer. 14.49. In the year 1997, what is the difference between the Savings(% of GNI) in Belize and Savings(% of GNI) in Slovak Republic?
Your answer should be compact. 11.92. In the year 1997, what is the difference between the Savings(% of GNI) in Belize and Savings(% of GNI) in South Africa?
Make the answer very short. 11.23. In the year 1997, what is the difference between the Savings(% of GNI) of Benin and Savings(% of GNI) of Slovak Republic?
Offer a very short reply. -2.57. In the year 1997, what is the difference between the Savings(% of GNI) in Benin and Savings(% of GNI) in South Africa?
Offer a terse response. -3.26. In the year 1997, what is the difference between the Savings(% of GNI) of Slovak Republic and Savings(% of GNI) of South Africa?
Give a very brief answer. -0.69. In the year 1998, what is the difference between the Savings(% of GNI) of Belize and Savings(% of GNI) of Benin?
Make the answer very short. 12.38. In the year 1998, what is the difference between the Savings(% of GNI) in Belize and Savings(% of GNI) in Slovak Republic?
Provide a short and direct response. 10.14. In the year 1998, what is the difference between the Savings(% of GNI) in Belize and Savings(% of GNI) in South Africa?
Offer a terse response. 9.07. In the year 1998, what is the difference between the Savings(% of GNI) of Benin and Savings(% of GNI) of Slovak Republic?
Give a very brief answer. -2.24. In the year 1998, what is the difference between the Savings(% of GNI) in Benin and Savings(% of GNI) in South Africa?
Your answer should be compact. -3.3. In the year 1998, what is the difference between the Savings(% of GNI) in Slovak Republic and Savings(% of GNI) in South Africa?
Offer a very short reply. -1.07. In the year 1999, what is the difference between the Savings(% of GNI) in Belize and Savings(% of GNI) in Benin?
Your response must be concise. 6.99. In the year 1999, what is the difference between the Savings(% of GNI) in Belize and Savings(% of GNI) in Slovak Republic?
Provide a short and direct response. 6.03. In the year 1999, what is the difference between the Savings(% of GNI) in Belize and Savings(% of GNI) in South Africa?
Offer a terse response. 4.01. In the year 1999, what is the difference between the Savings(% of GNI) of Benin and Savings(% of GNI) of Slovak Republic?
Give a very brief answer. -0.96. In the year 1999, what is the difference between the Savings(% of GNI) in Benin and Savings(% of GNI) in South Africa?
Provide a short and direct response. -2.98. In the year 1999, what is the difference between the Savings(% of GNI) in Slovak Republic and Savings(% of GNI) in South Africa?
Ensure brevity in your answer.  -2.03. In the year 2000, what is the difference between the Savings(% of GNI) in Belize and Savings(% of GNI) in Benin?
Your response must be concise. -5.17. In the year 2000, what is the difference between the Savings(% of GNI) in Belize and Savings(% of GNI) in Slovak Republic?
Provide a short and direct response. -3.29. In the year 2000, what is the difference between the Savings(% of GNI) of Belize and Savings(% of GNI) of South Africa?
Provide a short and direct response. -4.55. In the year 2000, what is the difference between the Savings(% of GNI) of Benin and Savings(% of GNI) of Slovak Republic?
Keep it short and to the point. 1.88. In the year 2000, what is the difference between the Savings(% of GNI) of Benin and Savings(% of GNI) of South Africa?
Provide a succinct answer. 0.62. In the year 2000, what is the difference between the Savings(% of GNI) of Slovak Republic and Savings(% of GNI) of South Africa?
Your response must be concise. -1.26. In the year 2002, what is the difference between the Savings(% of GNI) in Benin and Savings(% of GNI) in Slovak Republic?
Make the answer very short. -2.55. In the year 2002, what is the difference between the Savings(% of GNI) of Benin and Savings(% of GNI) of South Africa?
Make the answer very short. -4.45. In the year 2002, what is the difference between the Savings(% of GNI) in Slovak Republic and Savings(% of GNI) in South Africa?
Ensure brevity in your answer.  -1.9. In the year 2003, what is the difference between the Savings(% of GNI) in Slovak Republic and Savings(% of GNI) in South Africa?
Provide a short and direct response. -5.28. In the year 2004, what is the difference between the Savings(% of GNI) of Benin and Savings(% of GNI) of Slovak Republic?
Provide a short and direct response. -2.34. In the year 2004, what is the difference between the Savings(% of GNI) in Benin and Savings(% of GNI) in South Africa?
Offer a very short reply. -3.43. In the year 2004, what is the difference between the Savings(% of GNI) of Slovak Republic and Savings(% of GNI) of South Africa?
Provide a succinct answer. -1.08. In the year 2005, what is the difference between the Savings(% of GNI) in Benin and Savings(% of GNI) in Slovak Republic?
Keep it short and to the point. -2.87. In the year 2005, what is the difference between the Savings(% of GNI) in Benin and Savings(% of GNI) in South Africa?
Ensure brevity in your answer.  -3.04. In the year 2005, what is the difference between the Savings(% of GNI) of Slovak Republic and Savings(% of GNI) of South Africa?
Offer a very short reply. -0.17. What is the ratio of the Savings(% of GNI) of Belize in 1997 to that in 1998?
Your response must be concise. 1.18. What is the ratio of the Savings(% of GNI) of Benin in 1997 to that in 1998?
Ensure brevity in your answer.  1.21. What is the ratio of the Savings(% of GNI) in Slovak Republic in 1997 to that in 1998?
Your response must be concise. 1.19. What is the ratio of the Savings(% of GNI) of South Africa in 1997 to that in 1998?
Offer a terse response. 1.11. What is the ratio of the Savings(% of GNI) of Belize in 1997 to that in 1999?
Offer a very short reply. 1.75. What is the ratio of the Savings(% of GNI) of Benin in 1997 to that in 1999?
Your answer should be very brief. 1.2. What is the ratio of the Savings(% of GNI) of Slovak Republic in 1997 to that in 1999?
Make the answer very short. 1.48. What is the ratio of the Savings(% of GNI) of South Africa in 1997 to that in 1999?
Keep it short and to the point. 1.15. What is the ratio of the Savings(% of GNI) of Belize in 1997 to that in 2000?
Your answer should be compact. 12.9. What is the ratio of the Savings(% of GNI) in Benin in 1997 to that in 2000?
Your response must be concise. 0.73. What is the ratio of the Savings(% of GNI) of Slovak Republic in 1997 to that in 2000?
Your response must be concise. 1.55. What is the ratio of the Savings(% of GNI) in South Africa in 1997 to that in 2000?
Make the answer very short. 1.34. What is the ratio of the Savings(% of GNI) of Benin in 1997 to that in 2002?
Your response must be concise. 3.02. What is the ratio of the Savings(% of GNI) in Slovak Republic in 1997 to that in 2002?
Keep it short and to the point. 1.79. What is the ratio of the Savings(% of GNI) in South Africa in 1997 to that in 2002?
Keep it short and to the point. 1.34. What is the ratio of the Savings(% of GNI) in Slovak Republic in 1997 to that in 2003?
Offer a terse response. 16.73. What is the ratio of the Savings(% of GNI) of South Africa in 1997 to that in 2003?
Keep it short and to the point. 1.42. What is the ratio of the Savings(% of GNI) in Benin in 1997 to that in 2004?
Provide a short and direct response. 5.57. What is the ratio of the Savings(% of GNI) of Slovak Republic in 1997 to that in 2004?
Keep it short and to the point. 2.31. What is the ratio of the Savings(% of GNI) of South Africa in 1997 to that in 2004?
Make the answer very short. 1.89. What is the ratio of the Savings(% of GNI) in Benin in 1997 to that in 2005?
Offer a terse response. 2.76. What is the ratio of the Savings(% of GNI) in Slovak Republic in 1997 to that in 2005?
Keep it short and to the point. 1.6. What is the ratio of the Savings(% of GNI) in South Africa in 1997 to that in 2005?
Ensure brevity in your answer.  1.69. What is the ratio of the Savings(% of GNI) in Belize in 1998 to that in 1999?
Your answer should be very brief. 1.48. What is the ratio of the Savings(% of GNI) of Benin in 1998 to that in 1999?
Offer a very short reply. 0.99. What is the ratio of the Savings(% of GNI) in Slovak Republic in 1998 to that in 1999?
Provide a short and direct response. 1.24. What is the ratio of the Savings(% of GNI) of South Africa in 1998 to that in 1999?
Your answer should be very brief. 1.04. What is the ratio of the Savings(% of GNI) of Belize in 1998 to that in 2000?
Your response must be concise. 10.92. What is the ratio of the Savings(% of GNI) in Benin in 1998 to that in 2000?
Keep it short and to the point. 0.6. What is the ratio of the Savings(% of GNI) in Slovak Republic in 1998 to that in 2000?
Your response must be concise. 1.3. What is the ratio of the Savings(% of GNI) of South Africa in 1998 to that in 2000?
Give a very brief answer. 1.21. What is the ratio of the Savings(% of GNI) of Benin in 1998 to that in 2002?
Offer a terse response. 2.49. What is the ratio of the Savings(% of GNI) of Slovak Republic in 1998 to that in 2002?
Give a very brief answer. 1.5. What is the ratio of the Savings(% of GNI) of South Africa in 1998 to that in 2002?
Your answer should be very brief. 1.21. What is the ratio of the Savings(% of GNI) in Slovak Republic in 1998 to that in 2003?
Offer a very short reply. 14.05. What is the ratio of the Savings(% of GNI) of South Africa in 1998 to that in 2003?
Provide a short and direct response. 1.28. What is the ratio of the Savings(% of GNI) in Benin in 1998 to that in 2004?
Provide a short and direct response. 4.58. What is the ratio of the Savings(% of GNI) of Slovak Republic in 1998 to that in 2004?
Offer a terse response. 1.94. What is the ratio of the Savings(% of GNI) in South Africa in 1998 to that in 2004?
Your answer should be compact. 1.7. What is the ratio of the Savings(% of GNI) in Benin in 1998 to that in 2005?
Ensure brevity in your answer.  2.27. What is the ratio of the Savings(% of GNI) of Slovak Republic in 1998 to that in 2005?
Provide a short and direct response. 1.35. What is the ratio of the Savings(% of GNI) of South Africa in 1998 to that in 2005?
Ensure brevity in your answer.  1.52. What is the ratio of the Savings(% of GNI) in Belize in 1999 to that in 2000?
Offer a terse response. 7.37. What is the ratio of the Savings(% of GNI) of Benin in 1999 to that in 2000?
Offer a very short reply. 0.61. What is the ratio of the Savings(% of GNI) of Slovak Republic in 1999 to that in 2000?
Ensure brevity in your answer.  1.05. What is the ratio of the Savings(% of GNI) in South Africa in 1999 to that in 2000?
Offer a very short reply. 1.16. What is the ratio of the Savings(% of GNI) of Benin in 1999 to that in 2002?
Provide a succinct answer. 2.52. What is the ratio of the Savings(% of GNI) of Slovak Republic in 1999 to that in 2002?
Your response must be concise. 1.21. What is the ratio of the Savings(% of GNI) in South Africa in 1999 to that in 2002?
Provide a succinct answer. 1.16. What is the ratio of the Savings(% of GNI) of Slovak Republic in 1999 to that in 2003?
Your answer should be very brief. 11.3. What is the ratio of the Savings(% of GNI) of South Africa in 1999 to that in 2003?
Keep it short and to the point. 1.23. What is the ratio of the Savings(% of GNI) in Benin in 1999 to that in 2004?
Offer a very short reply. 4.65. What is the ratio of the Savings(% of GNI) of Slovak Republic in 1999 to that in 2004?
Keep it short and to the point. 1.56. What is the ratio of the Savings(% of GNI) in South Africa in 1999 to that in 2004?
Ensure brevity in your answer.  1.64. What is the ratio of the Savings(% of GNI) in Benin in 1999 to that in 2005?
Offer a very short reply. 2.31. What is the ratio of the Savings(% of GNI) of Slovak Republic in 1999 to that in 2005?
Keep it short and to the point. 1.08. What is the ratio of the Savings(% of GNI) of South Africa in 1999 to that in 2005?
Provide a short and direct response. 1.47. What is the ratio of the Savings(% of GNI) of Benin in 2000 to that in 2002?
Ensure brevity in your answer.  4.15. What is the ratio of the Savings(% of GNI) in Slovak Republic in 2000 to that in 2002?
Keep it short and to the point. 1.15. What is the ratio of the Savings(% of GNI) in Slovak Republic in 2000 to that in 2003?
Your answer should be compact. 10.78. What is the ratio of the Savings(% of GNI) of South Africa in 2000 to that in 2003?
Keep it short and to the point. 1.06. What is the ratio of the Savings(% of GNI) in Benin in 2000 to that in 2004?
Keep it short and to the point. 7.64. What is the ratio of the Savings(% of GNI) of Slovak Republic in 2000 to that in 2004?
Ensure brevity in your answer.  1.49. What is the ratio of the Savings(% of GNI) of South Africa in 2000 to that in 2004?
Your response must be concise. 1.41. What is the ratio of the Savings(% of GNI) in Benin in 2000 to that in 2005?
Your answer should be compact. 3.79. What is the ratio of the Savings(% of GNI) in Slovak Republic in 2000 to that in 2005?
Provide a short and direct response. 1.03. What is the ratio of the Savings(% of GNI) of South Africa in 2000 to that in 2005?
Provide a succinct answer. 1.26. What is the ratio of the Savings(% of GNI) of Slovak Republic in 2002 to that in 2003?
Make the answer very short. 9.36. What is the ratio of the Savings(% of GNI) in South Africa in 2002 to that in 2003?
Offer a terse response. 1.06. What is the ratio of the Savings(% of GNI) of Benin in 2002 to that in 2004?
Your response must be concise. 1.84. What is the ratio of the Savings(% of GNI) of Slovak Republic in 2002 to that in 2004?
Offer a very short reply. 1.29. What is the ratio of the Savings(% of GNI) in South Africa in 2002 to that in 2004?
Offer a terse response. 1.41. What is the ratio of the Savings(% of GNI) in Benin in 2002 to that in 2005?
Your answer should be compact. 0.91. What is the ratio of the Savings(% of GNI) of Slovak Republic in 2002 to that in 2005?
Offer a terse response. 0.9. What is the ratio of the Savings(% of GNI) of South Africa in 2002 to that in 2005?
Ensure brevity in your answer.  1.26. What is the ratio of the Savings(% of GNI) of Slovak Republic in 2003 to that in 2004?
Provide a short and direct response. 0.14. What is the ratio of the Savings(% of GNI) of South Africa in 2003 to that in 2004?
Provide a short and direct response. 1.33. What is the ratio of the Savings(% of GNI) of Slovak Republic in 2003 to that in 2005?
Offer a very short reply. 0.1. What is the ratio of the Savings(% of GNI) in South Africa in 2003 to that in 2005?
Your response must be concise. 1.19. What is the ratio of the Savings(% of GNI) of Benin in 2004 to that in 2005?
Your answer should be very brief. 0.5. What is the ratio of the Savings(% of GNI) of Slovak Republic in 2004 to that in 2005?
Provide a short and direct response. 0.69. What is the ratio of the Savings(% of GNI) in South Africa in 2004 to that in 2005?
Your answer should be compact. 0.9. What is the difference between the highest and the second highest Savings(% of GNI) of Belize?
Keep it short and to the point. 2.97. What is the difference between the highest and the second highest Savings(% of GNI) in Benin?
Offer a very short reply. 1.81. What is the difference between the highest and the second highest Savings(% of GNI) of Slovak Republic?
Your answer should be compact. 1.19. What is the difference between the highest and the second highest Savings(% of GNI) of South Africa?
Your answer should be very brief. 0.81. What is the difference between the highest and the lowest Savings(% of GNI) of Belize?
Offer a terse response. 19.35. What is the difference between the highest and the lowest Savings(% of GNI) of Benin?
Give a very brief answer. 6.67. What is the difference between the highest and the lowest Savings(% of GNI) of Slovak Republic?
Offer a very short reply. 6.98. What is the difference between the highest and the lowest Savings(% of GNI) in South Africa?
Offer a very short reply. 3.82. 